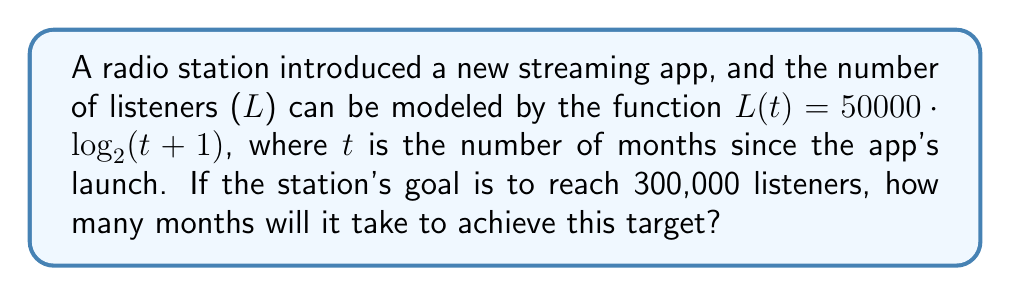Teach me how to tackle this problem. To solve this problem, we need to use the given logarithmic function and solve for t when L = 300,000.

Step 1: Set up the equation
$300000 = 50000 \cdot \log_2(t+1)$

Step 2: Divide both sides by 50000
$6 = \log_2(t+1)$

Step 3: Apply the inverse function (exponential) to both sides
$2^6 = t+1$

Step 4: Simplify the left side
$64 = t+1$

Step 5: Solve for t
$t = 64 - 1 = 63$

Therefore, it will take 63 months to reach the target of 300,000 listeners.
Answer: 63 months 